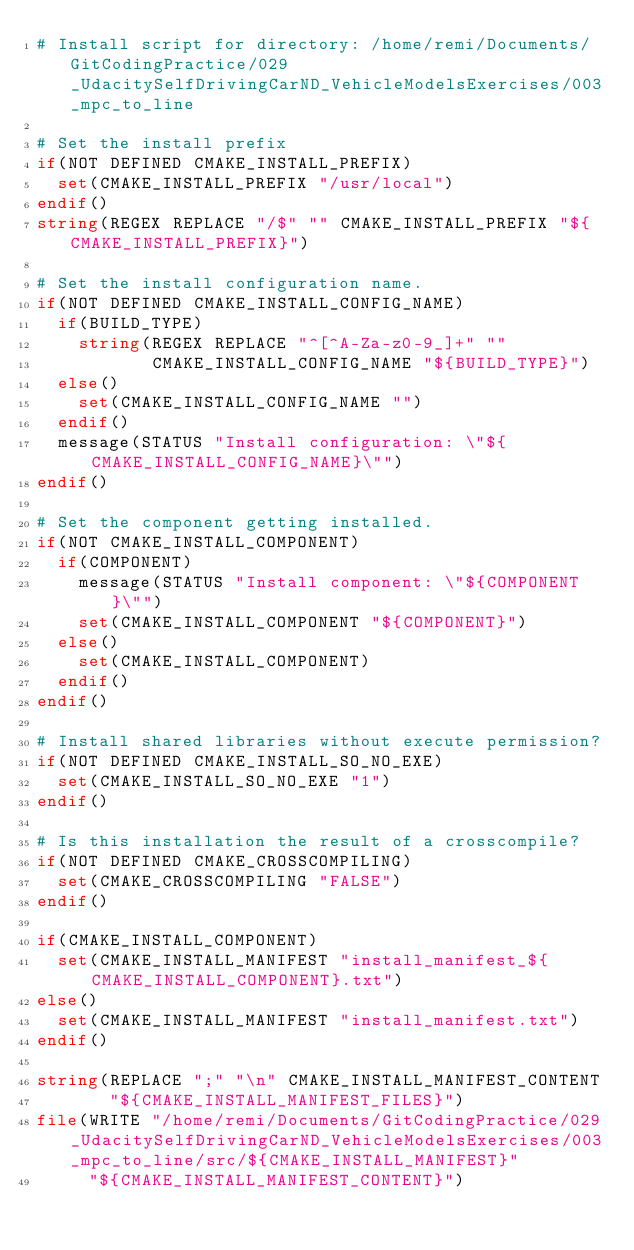Convert code to text. <code><loc_0><loc_0><loc_500><loc_500><_CMake_># Install script for directory: /home/remi/Documents/GitCodingPractice/029_UdacitySelfDrivingCarND_VehicleModelsExercises/003_mpc_to_line

# Set the install prefix
if(NOT DEFINED CMAKE_INSTALL_PREFIX)
  set(CMAKE_INSTALL_PREFIX "/usr/local")
endif()
string(REGEX REPLACE "/$" "" CMAKE_INSTALL_PREFIX "${CMAKE_INSTALL_PREFIX}")

# Set the install configuration name.
if(NOT DEFINED CMAKE_INSTALL_CONFIG_NAME)
  if(BUILD_TYPE)
    string(REGEX REPLACE "^[^A-Za-z0-9_]+" ""
           CMAKE_INSTALL_CONFIG_NAME "${BUILD_TYPE}")
  else()
    set(CMAKE_INSTALL_CONFIG_NAME "")
  endif()
  message(STATUS "Install configuration: \"${CMAKE_INSTALL_CONFIG_NAME}\"")
endif()

# Set the component getting installed.
if(NOT CMAKE_INSTALL_COMPONENT)
  if(COMPONENT)
    message(STATUS "Install component: \"${COMPONENT}\"")
    set(CMAKE_INSTALL_COMPONENT "${COMPONENT}")
  else()
    set(CMAKE_INSTALL_COMPONENT)
  endif()
endif()

# Install shared libraries without execute permission?
if(NOT DEFINED CMAKE_INSTALL_SO_NO_EXE)
  set(CMAKE_INSTALL_SO_NO_EXE "1")
endif()

# Is this installation the result of a crosscompile?
if(NOT DEFINED CMAKE_CROSSCOMPILING)
  set(CMAKE_CROSSCOMPILING "FALSE")
endif()

if(CMAKE_INSTALL_COMPONENT)
  set(CMAKE_INSTALL_MANIFEST "install_manifest_${CMAKE_INSTALL_COMPONENT}.txt")
else()
  set(CMAKE_INSTALL_MANIFEST "install_manifest.txt")
endif()

string(REPLACE ";" "\n" CMAKE_INSTALL_MANIFEST_CONTENT
       "${CMAKE_INSTALL_MANIFEST_FILES}")
file(WRITE "/home/remi/Documents/GitCodingPractice/029_UdacitySelfDrivingCarND_VehicleModelsExercises/003_mpc_to_line/src/${CMAKE_INSTALL_MANIFEST}"
     "${CMAKE_INSTALL_MANIFEST_CONTENT}")
</code> 